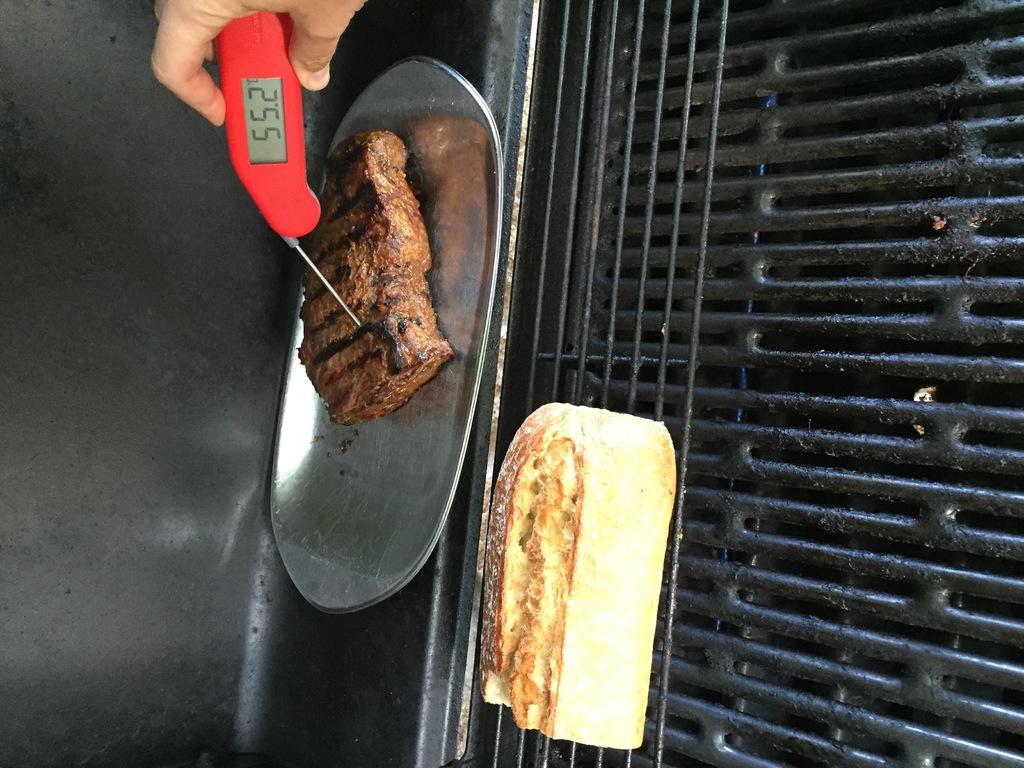What is the temperature of this meat?
Offer a terse response. 55.2. 